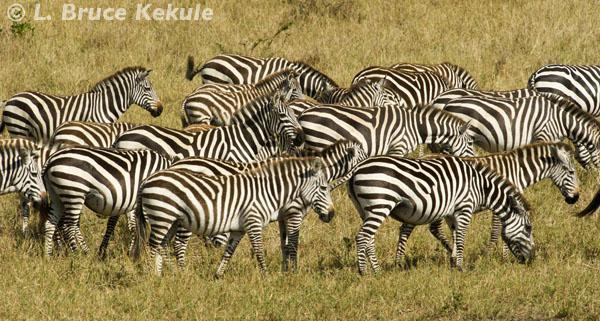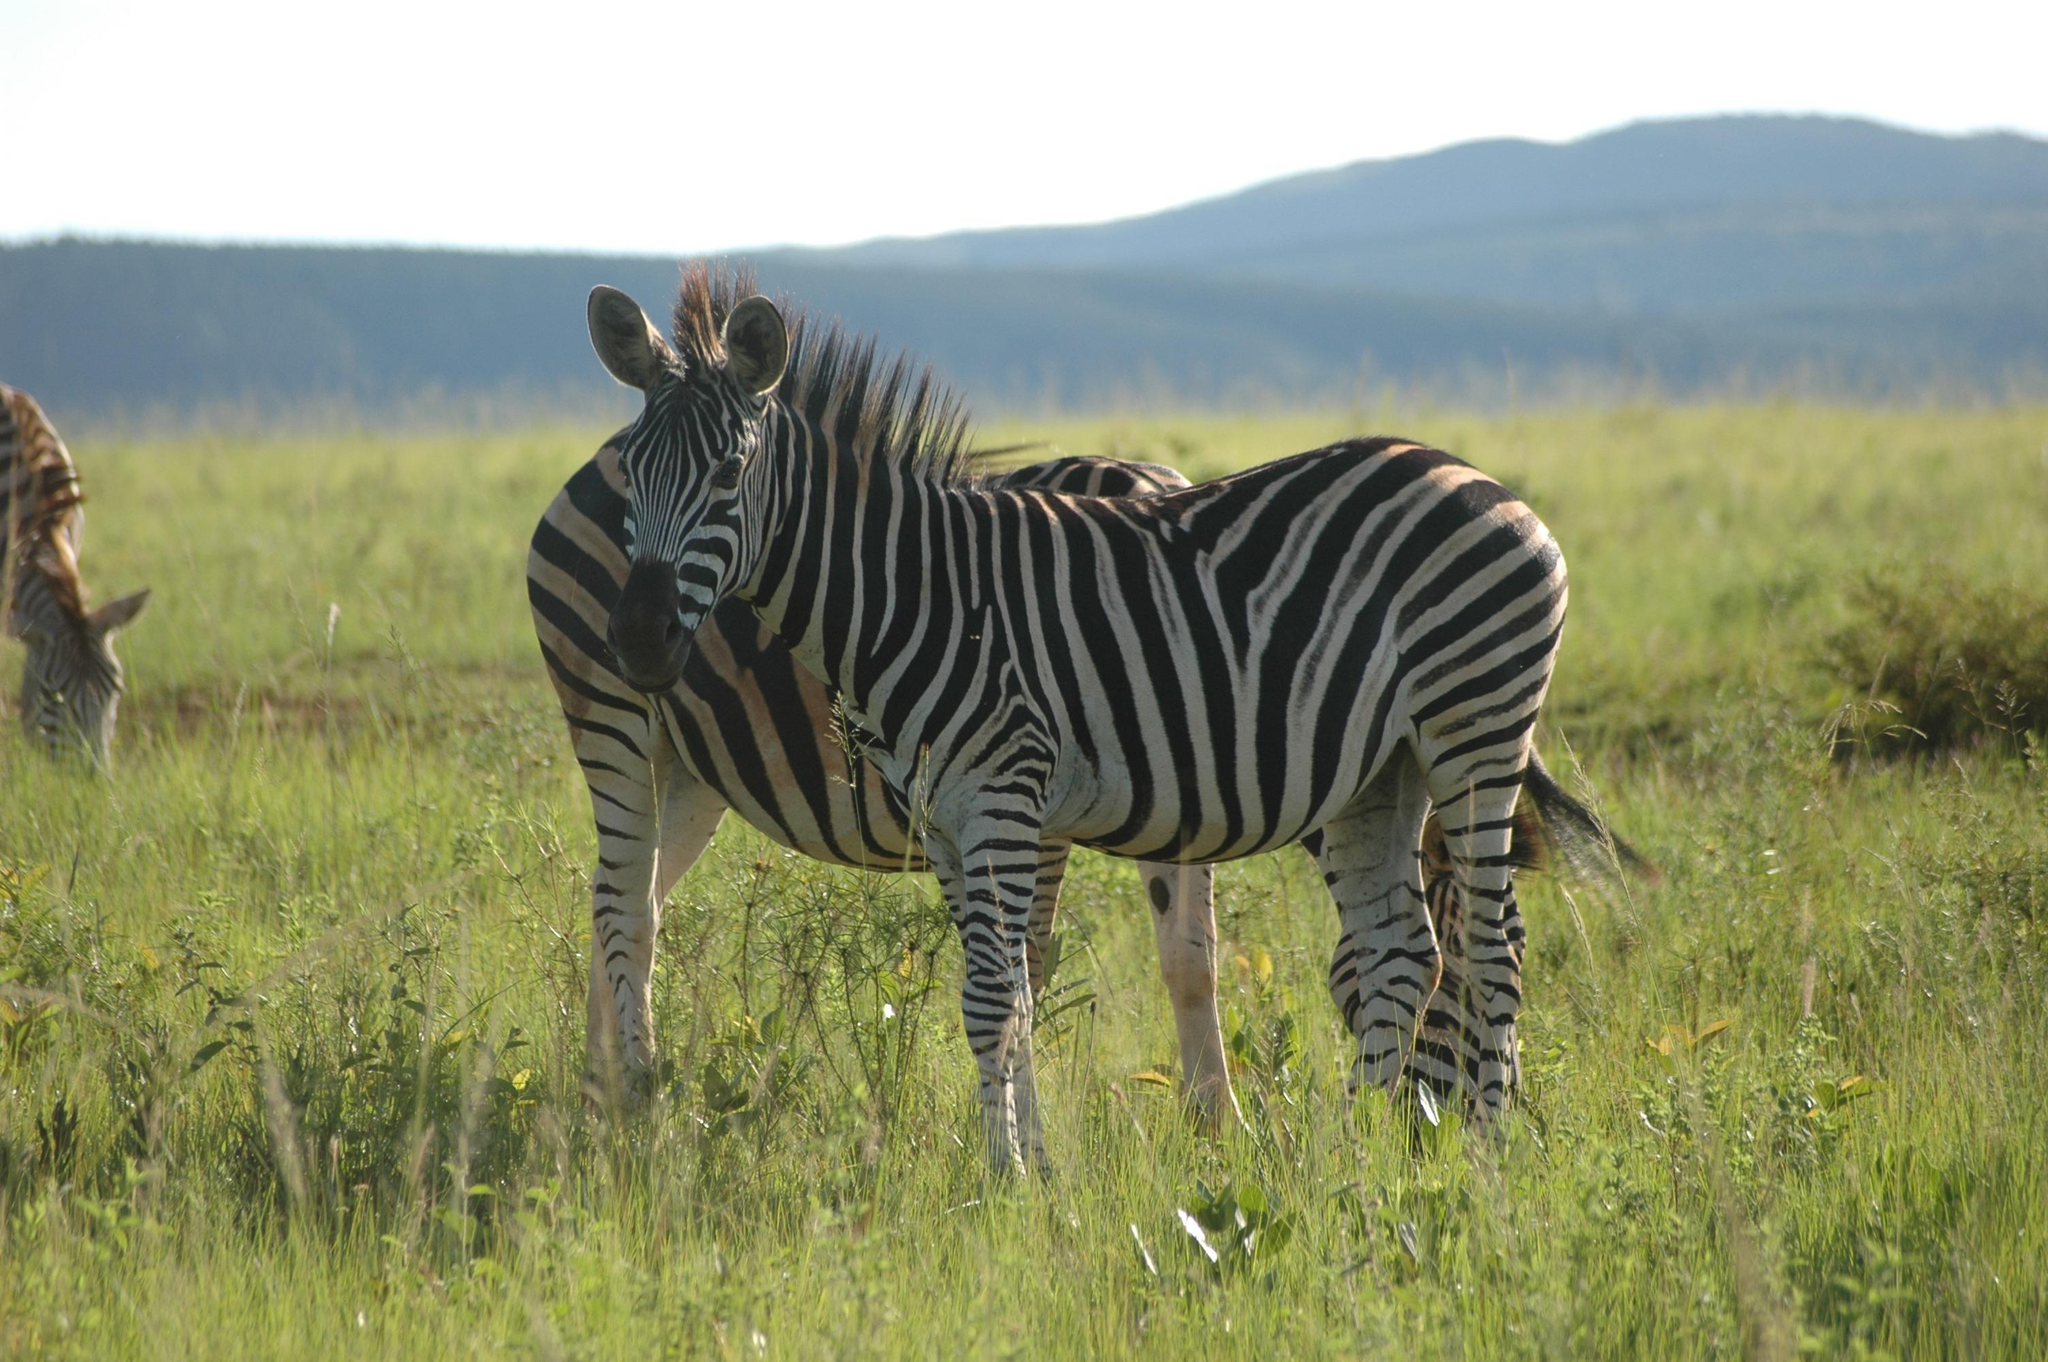The first image is the image on the left, the second image is the image on the right. Given the left and right images, does the statement "The left image contains at least three times as many zebras as the right image." hold true? Answer yes or no. Yes. The first image is the image on the left, the second image is the image on the right. Considering the images on both sides, is "In one image there are exactly three zebras present and the other shows more than three." valid? Answer yes or no. Yes. 